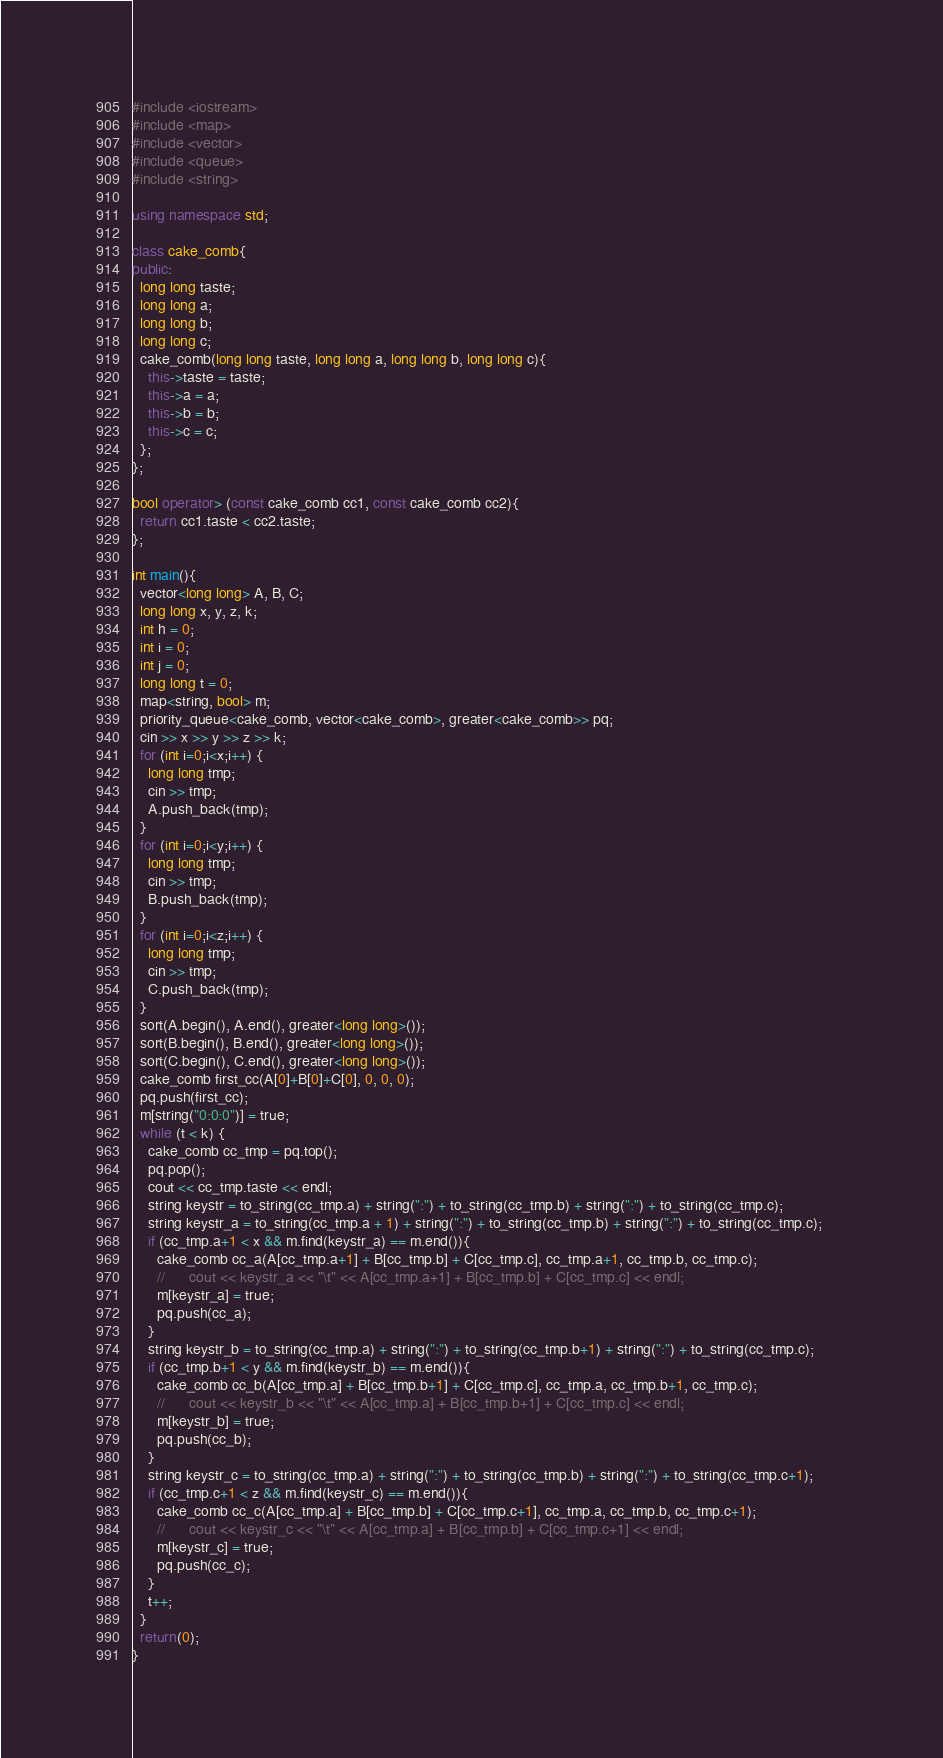Convert code to text. <code><loc_0><loc_0><loc_500><loc_500><_C++_>#include <iostream>
#include <map>
#include <vector>
#include <queue>
#include <string>

using namespace std;

class cake_comb{
public:
  long long taste;
  long long a;
  long long b;
  long long c;
  cake_comb(long long taste, long long a, long long b, long long c){
    this->taste = taste;
    this->a = a;
    this->b = b;
    this->c = c;
  };
};

bool operator> (const cake_comb cc1, const cake_comb cc2){
  return cc1.taste < cc2.taste;
};

int main(){
  vector<long long> A, B, C;
  long long x, y, z, k;
  int h = 0;
  int i = 0;
  int j = 0;
  long long t = 0;
  map<string, bool> m;
  priority_queue<cake_comb, vector<cake_comb>, greater<cake_comb>> pq;
  cin >> x >> y >> z >> k;
  for (int i=0;i<x;i++) {
    long long tmp;
    cin >> tmp;
    A.push_back(tmp);
  }
  for (int i=0;i<y;i++) {
    long long tmp;
    cin >> tmp;
    B.push_back(tmp);
  }
  for (int i=0;i<z;i++) {
    long long tmp;
    cin >> tmp;
    C.push_back(tmp);
  }
  sort(A.begin(), A.end(), greater<long long>());
  sort(B.begin(), B.end(), greater<long long>());
  sort(C.begin(), C.end(), greater<long long>());
  cake_comb first_cc(A[0]+B[0]+C[0], 0, 0, 0);
  pq.push(first_cc);
  m[string("0:0:0")] = true;
  while (t < k) {
    cake_comb cc_tmp = pq.top();
    pq.pop();
    cout << cc_tmp.taste << endl;
    string keystr = to_string(cc_tmp.a) + string(":") + to_string(cc_tmp.b) + string(":") + to_string(cc_tmp.c);
    string keystr_a = to_string(cc_tmp.a + 1) + string(":") + to_string(cc_tmp.b) + string(":") + to_string(cc_tmp.c);      
    if (cc_tmp.a+1 < x && m.find(keystr_a) == m.end()){
      cake_comb cc_a(A[cc_tmp.a+1] + B[cc_tmp.b] + C[cc_tmp.c], cc_tmp.a+1, cc_tmp.b, cc_tmp.c);
      //      cout << keystr_a << "\t" << A[cc_tmp.a+1] + B[cc_tmp.b] + C[cc_tmp.c] << endl;
      m[keystr_a] = true;
      pq.push(cc_a);
    }
    string keystr_b = to_string(cc_tmp.a) + string(":") + to_string(cc_tmp.b+1) + string(":") + to_string(cc_tmp.c);      
    if (cc_tmp.b+1 < y && m.find(keystr_b) == m.end()){
      cake_comb cc_b(A[cc_tmp.a] + B[cc_tmp.b+1] + C[cc_tmp.c], cc_tmp.a, cc_tmp.b+1, cc_tmp.c);
      //      cout << keystr_b << "\t" << A[cc_tmp.a] + B[cc_tmp.b+1] + C[cc_tmp.c] << endl;
      m[keystr_b] = true;
      pq.push(cc_b);
    }
    string keystr_c = to_string(cc_tmp.a) + string(":") + to_string(cc_tmp.b) + string(":") + to_string(cc_tmp.c+1);      
    if (cc_tmp.c+1 < z && m.find(keystr_c) == m.end()){
      cake_comb cc_c(A[cc_tmp.a] + B[cc_tmp.b] + C[cc_tmp.c+1], cc_tmp.a, cc_tmp.b, cc_tmp.c+1);
      //      cout << keystr_c << "\t" << A[cc_tmp.a] + B[cc_tmp.b] + C[cc_tmp.c+1] << endl;
      m[keystr_c] = true;
      pq.push(cc_c);
    }
    t++;
  }
  return(0);
}


</code> 